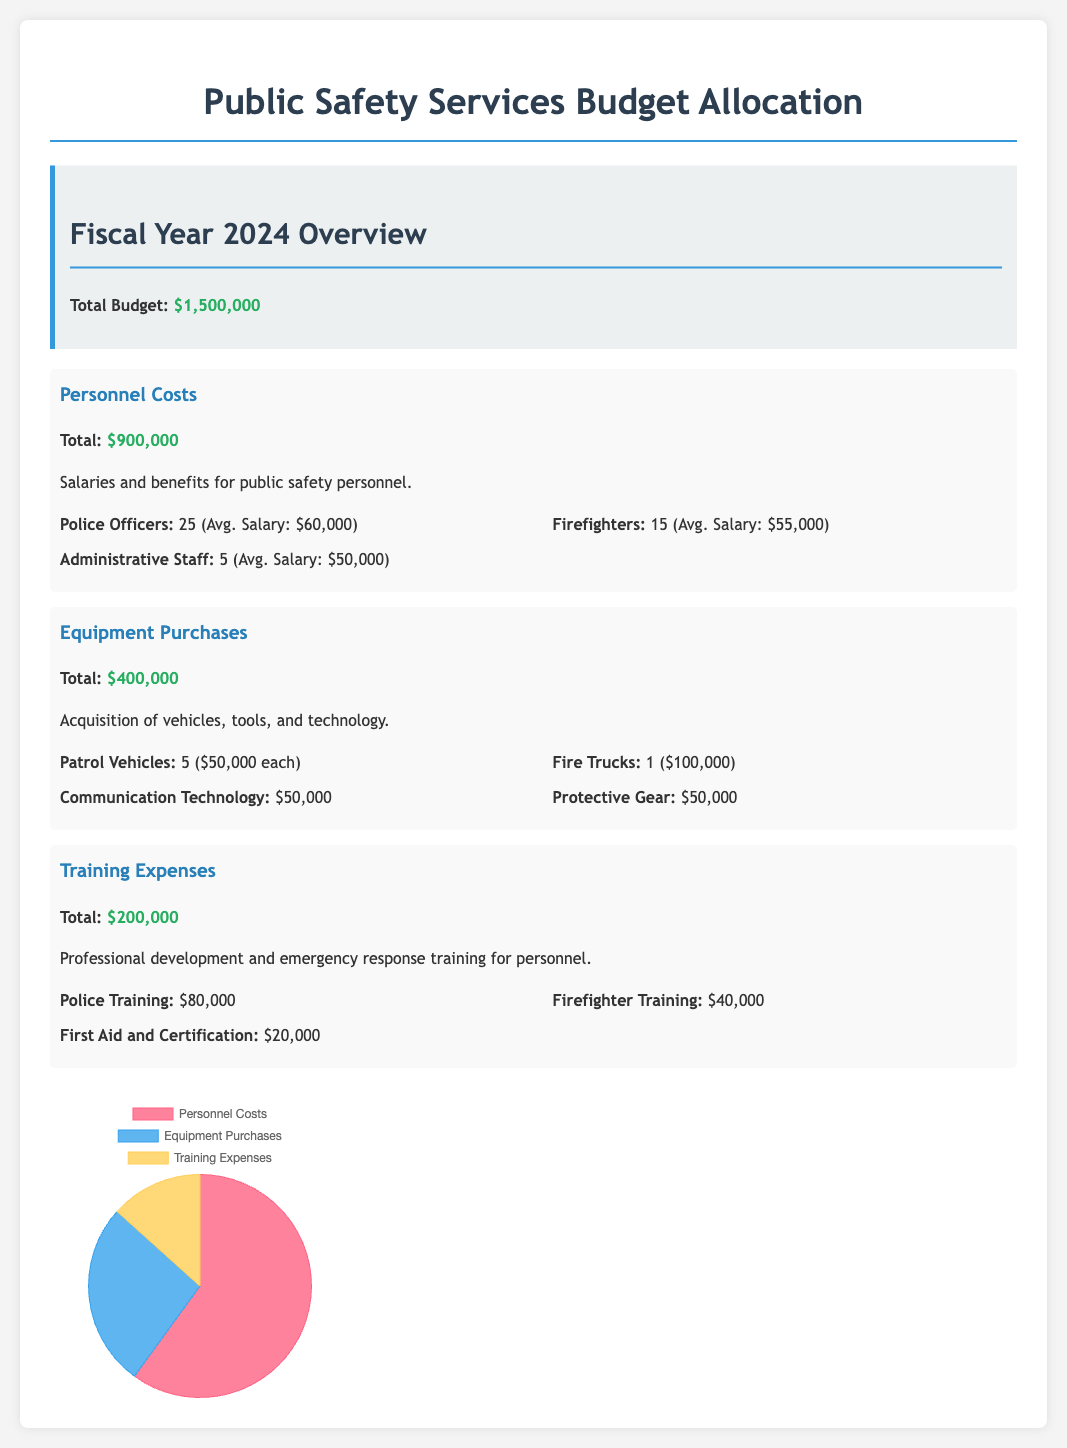What is the total budget for FY 2024? The total budget is outlined in the budget summary section, which states that the total budget is $1,500,000.
Answer: $1,500,000 How much is allocated for personnel costs? The personnel costs are listed under the relevant budget item, which states a total of $900,000.
Answer: $900,000 What is the average salary for firefighters? The average salary for firefighters is provided in the personnel costs section, which states it is $55,000.
Answer: $55,000 How many patrol vehicles are included in the equipment purchases? The number of patrol vehicles is mentioned in the equipment purchases section, indicating 5 vehicles.
Answer: 5 What percentage of the total budget is allocated to training expenses? Training expenses ($200,000) as a percentage of the total budget ($1,500,000) can be calculated, indicating that training expenses represent 13.33% of the budget.
Answer: 13.33% Which category has the highest allocation in the budget? The category with the highest allocation is identified in the budget document, which mentions personnel costs totaling $900,000.
Answer: Personnel Costs What is the total amount allocated for police training? The total amount allocated for police training is detailed in the training expenses section, showing $80,000.
Answer: $80,000 What type of gear is included in equipment purchases? The equipment purchases section mentions protective gear, which is specifically listed with a total of $50,000.
Answer: Protective Gear How many administrative staff positions are included in personnel costs? The number of administrative staff positions is mentioned in the personnel costs section, indicating 5 positions.
Answer: 5 